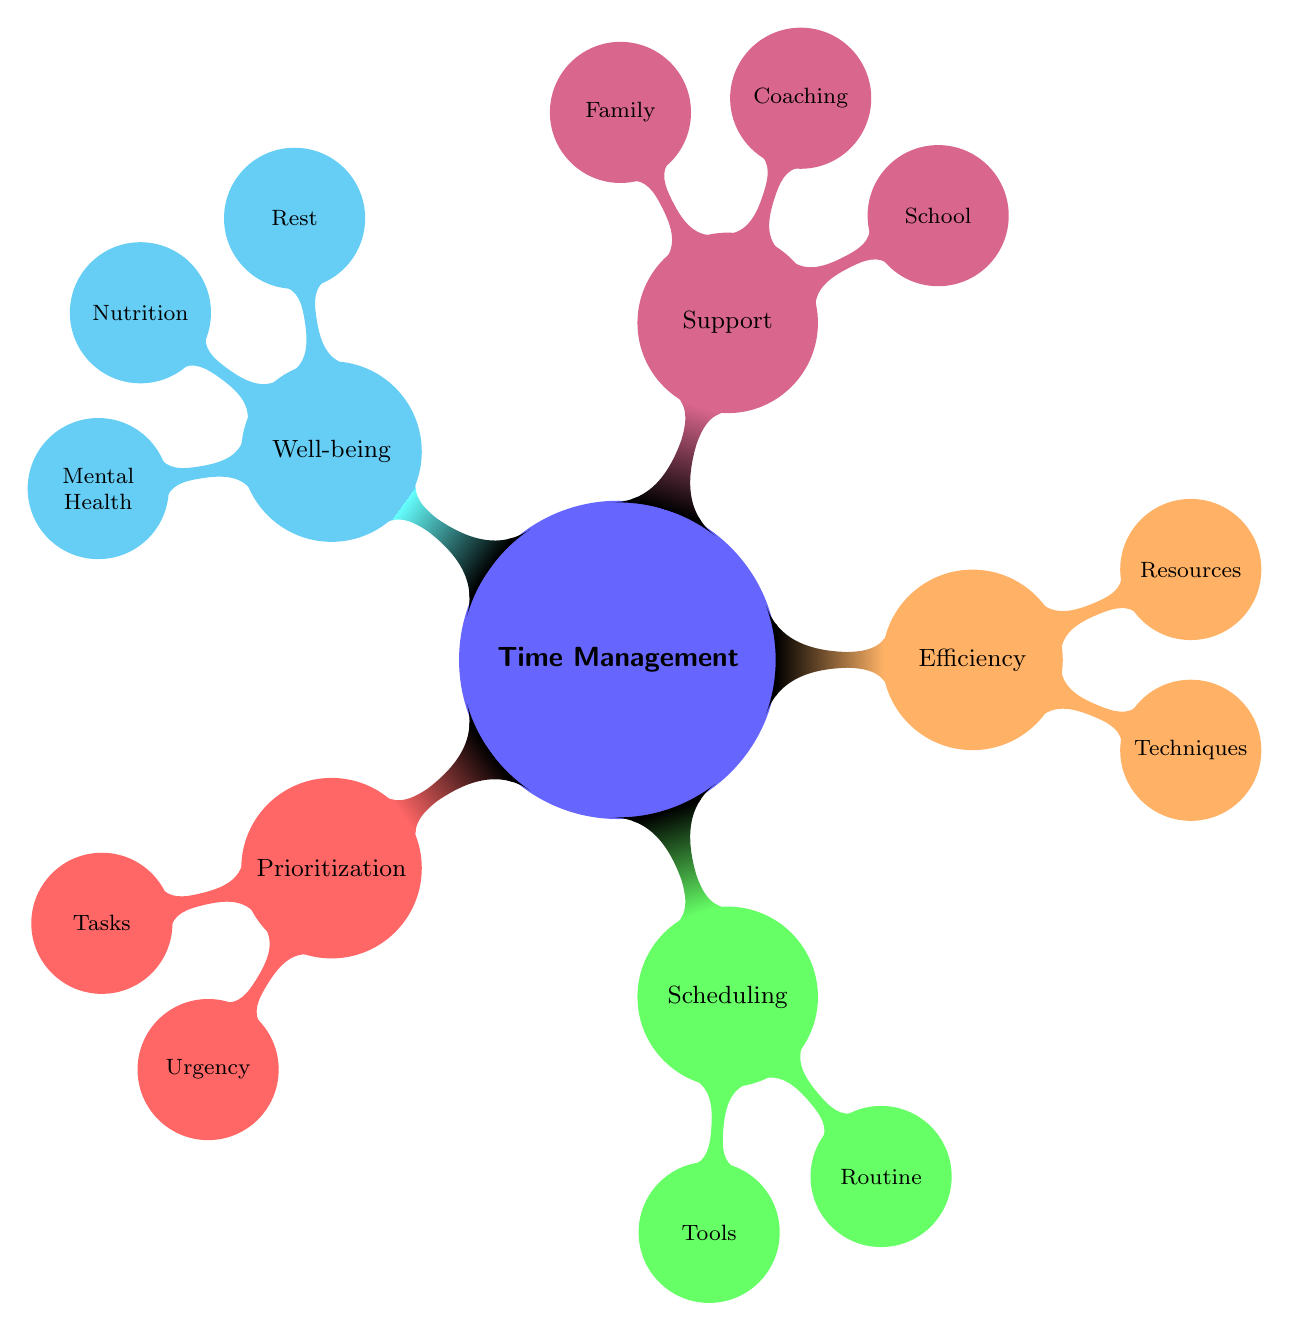What are the core elements of time management in the diagram? The diagram displays five core elements: Prioritization, Scheduling, Efficiency, Support, and Well-being, which are represented as branches stemming from the central concept of time management.
Answer: Prioritization, Scheduling, Efficiency, Support, Well-being How many tools are listed under Scheduling? Under the Scheduling branch, there are two tools mentioned: Planner and Calendar App. Counting these gives us the answer.
Answer: 2 What type of support is provided by family according to the diagram? The diagram lists two forms of support provided by family, which are Transportation Assistance and Moral Support, both found within the Support branch under Family.
Answer: Transportation Assistance, Moral Support Which technique is mentioned under Efficiency? The Efficiency category includes techniques, one of which is the Pomodoro Method, making it the answer to this question.
Answer: Pomodoro Method Which core element focuses on rest and nutrition? The Well-being core element encompasses both Rest and Nutrition, indicating that the diagram connects these concepts to maintaining overall wellness in time management.
Answer: Well-being What is the relationship between Tasks and Urgency in the Prioritization section? In the diagram, Tasks are categorized under the Prioritization core element, and Urgency categorizes the importance of these tasks based on criteria like Due Dates and Test Dates. The relationship shows how tasks are prioritized according to their urgency.
Answer: Tasks influence Urgency What type of resources are listed under Efficiency? Under the Efficiency branch, there are two categories listed as resources: Online Study Guides and Workout Plans. Gathering this from the diagram leads to the answer.
Answer: Online Study Guides, Workout Plans How many aspects of well-being are highlighted in the diagram? The Well-being section of the diagram identifies three aspects: Rest, Nutrition, and Mental Health. Summing these aspects provides the answer to the query.
Answer: 3 What does the diagram suggest about feedback sessions? Feedback Sessions are categorized under the Coaching branch in the Support core element, indicating they provide direct feedback to assist athletes. This understanding reflects the supportive role of feedback in the context of time management.
Answer: Coaching 